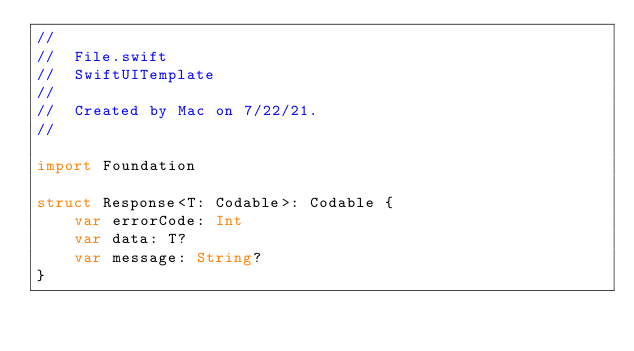<code> <loc_0><loc_0><loc_500><loc_500><_Swift_>//
//  File.swift
//  SwiftUITemplate
//
//  Created by Mac on 7/22/21.
//

import Foundation

struct Response<T: Codable>: Codable {
    var errorCode: Int
    var data: T?
    var message: String?
}
</code> 